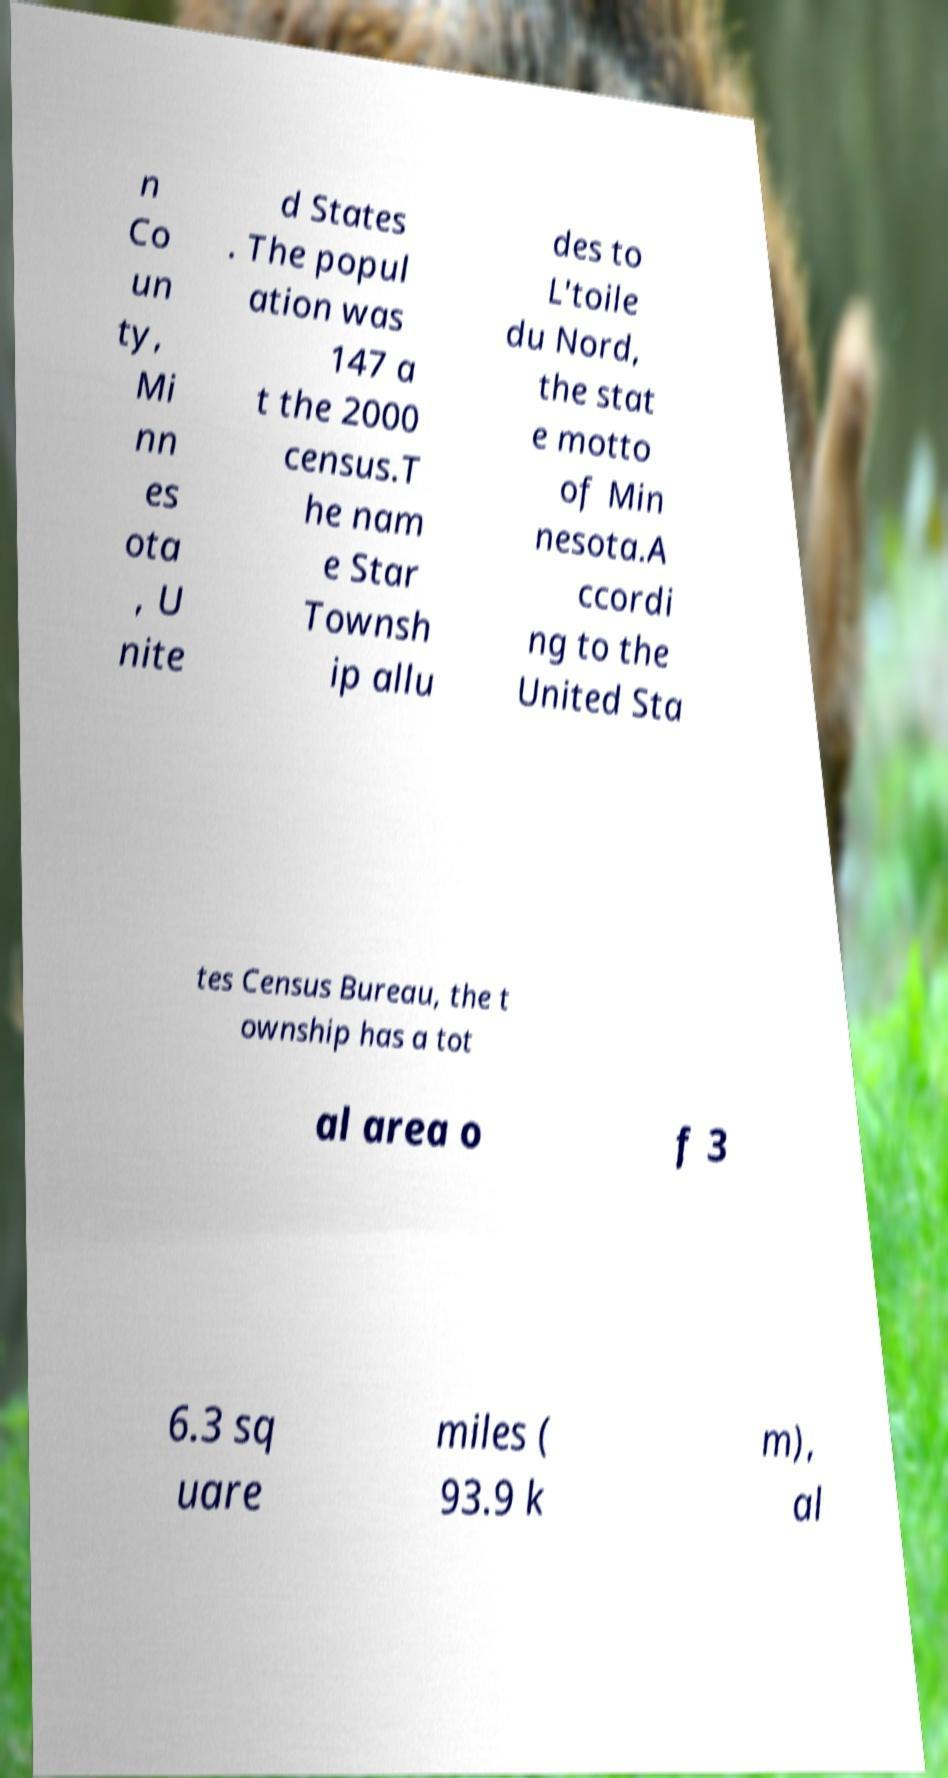There's text embedded in this image that I need extracted. Can you transcribe it verbatim? n Co un ty, Mi nn es ota , U nite d States . The popul ation was 147 a t the 2000 census.T he nam e Star Townsh ip allu des to L'toile du Nord, the stat e motto of Min nesota.A ccordi ng to the United Sta tes Census Bureau, the t ownship has a tot al area o f 3 6.3 sq uare miles ( 93.9 k m), al 